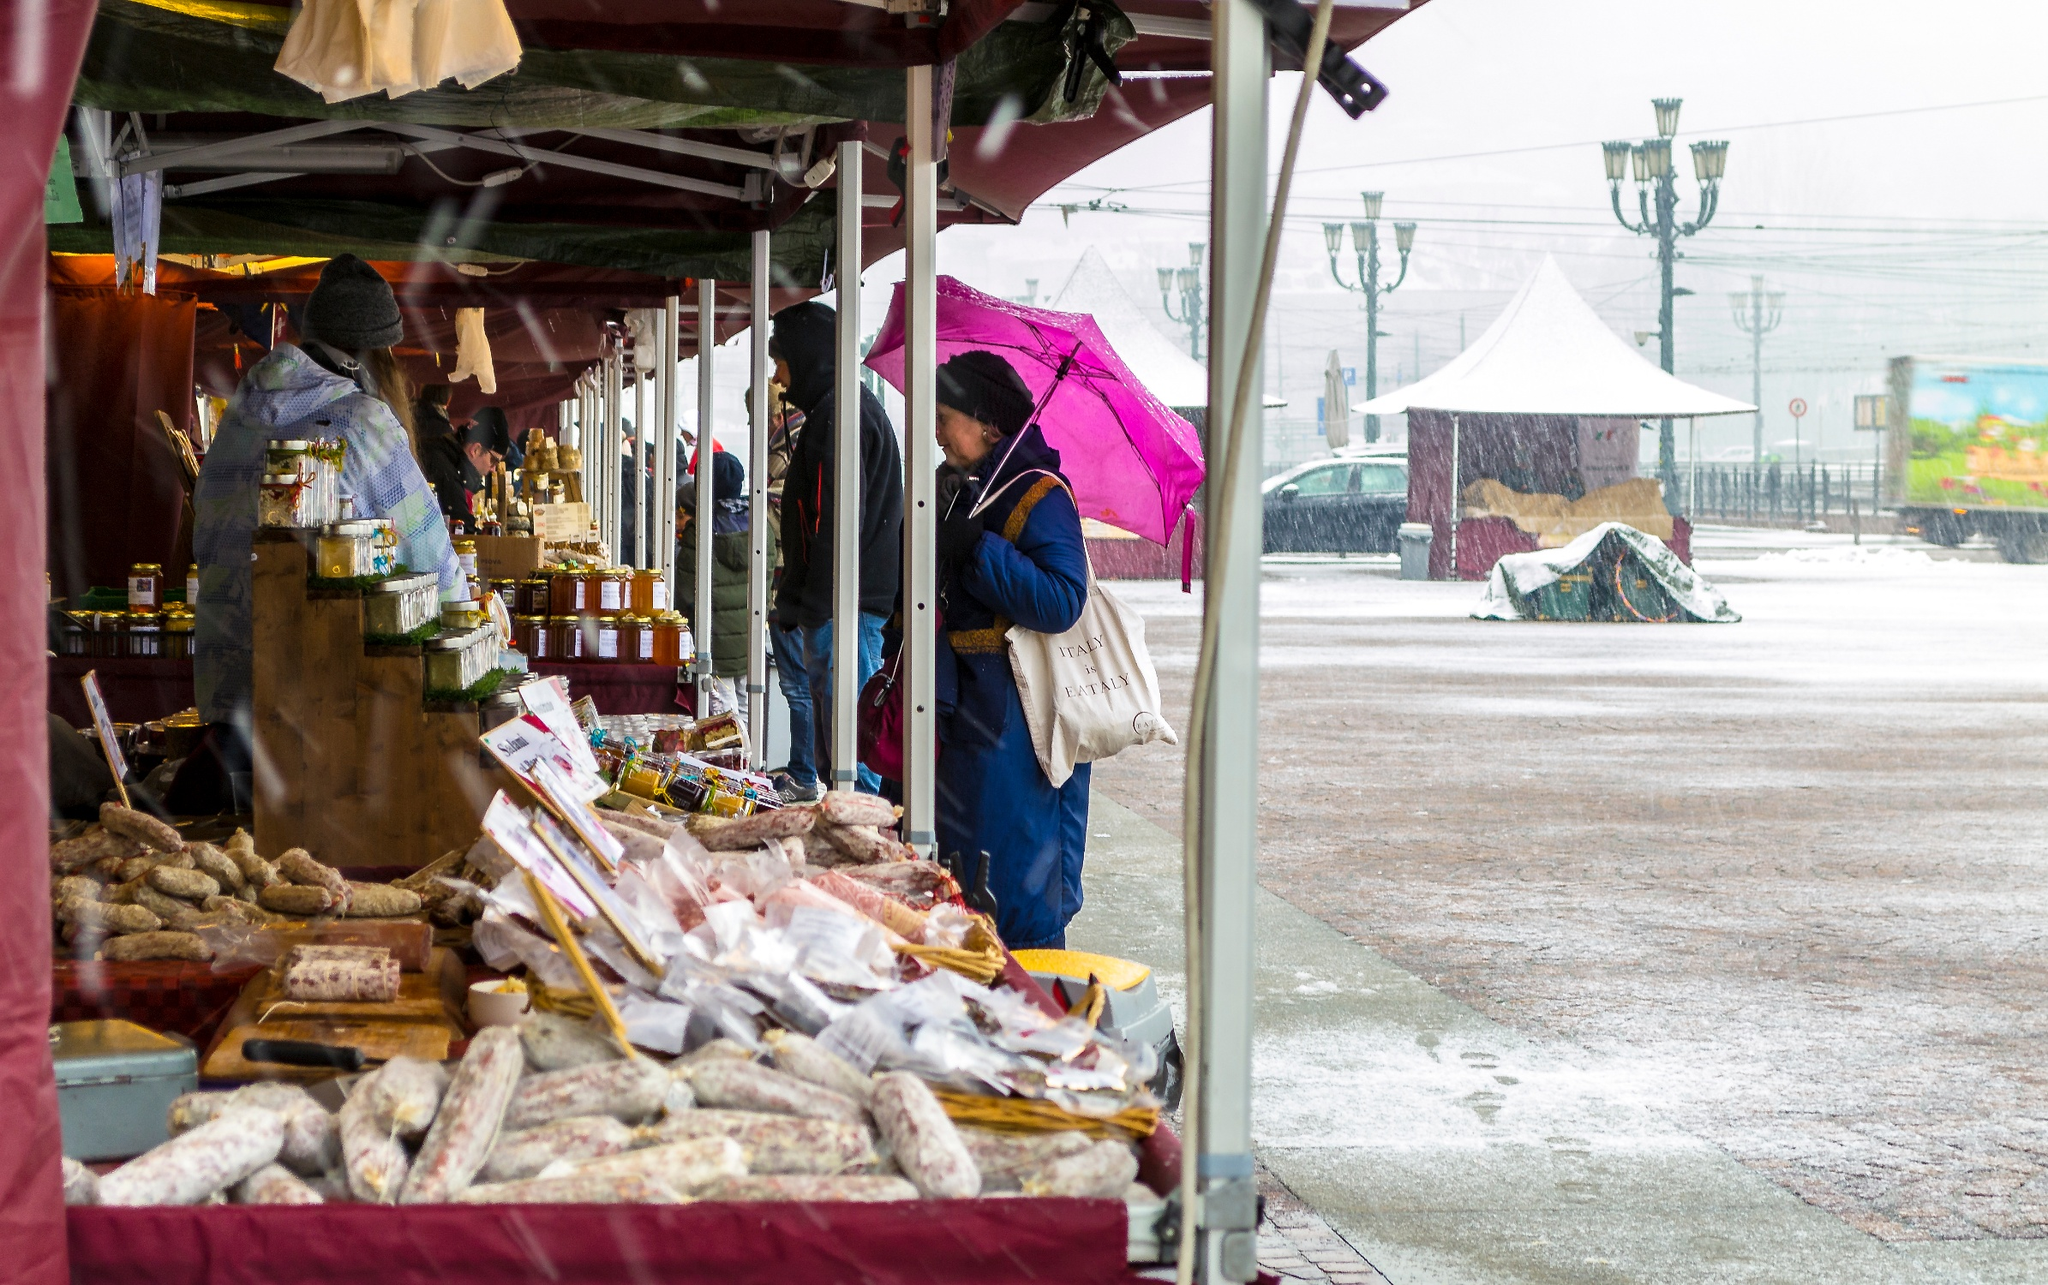What does the scene evoke in terms of atmosphere and setting? The scene evokes a charming, quaint atmosphere typical of a local marketplace. The overcast, rainy day adds a touch of nostalgia and coziness, as the market stalls and their canopies offer shelter and warmth. The cobblestone streets glisten from the rain, enhancing the picturesque setting. The presence of a vendor interacting with a customer under a bright pink umbrella adds a splash of color and highlights the human element of the scene, making it feel lively and vibrant despite the gloomy weather. Overall, it conveys a sense of community and the simple pleasures of daily life in a small town. What would the scene look like if it were a painting by a famous artist? If this scene were a painting by a famous artist, let’s say by Claude Monet, it would likely be an impressionistic masterpiece. Monet would capture the essence of the market with soft, blurry edges and vibrant, diffused light. The colors might be slightly exaggerated, with the maroon canopies appearing almost burgundy and the pink umbrella a striking focal point. The glistening cobblestones would shimmer with subtle reflections of the stalls and people. Monet would play with the light and shadows, giving a dreamy quality to the rainy day. The background might be rendered with less detail to focus the viewer’s attention on the bustling activity and the interaction between the vendor and the customer, creating a sense of warmth and community despite the rain. Imagine if the scene were part of a movie set in a post-apocalyptic world. How would the market be depicted? In a post-apocalyptic setting, this market scene would take on entirely different characteristics. The canopy, although still maroon, might appear tattered and worn, showing signs of makeshift repairs and patches. The stalls would be cobbled together with salvaged materials, and the food items might include more preserved goods and survival supplies rather than fresh produce. The vendors and customers would likely be dressed in rugged, utilitarian clothing, reflecting the harsh realities of their world. The surroundings might show signs of decay, with crumbling buildings in the background and a more desolate, eerie atmosphere replacing the quaint charm. The interactions between people would be more pragmatic, focused on bartering and survival, underscoring the resilience and adaptability of humanity even in dire circumstances. Despite the bleak setting, the market could still serve as a beacon of hope and community in a world struggling to rebuild. 